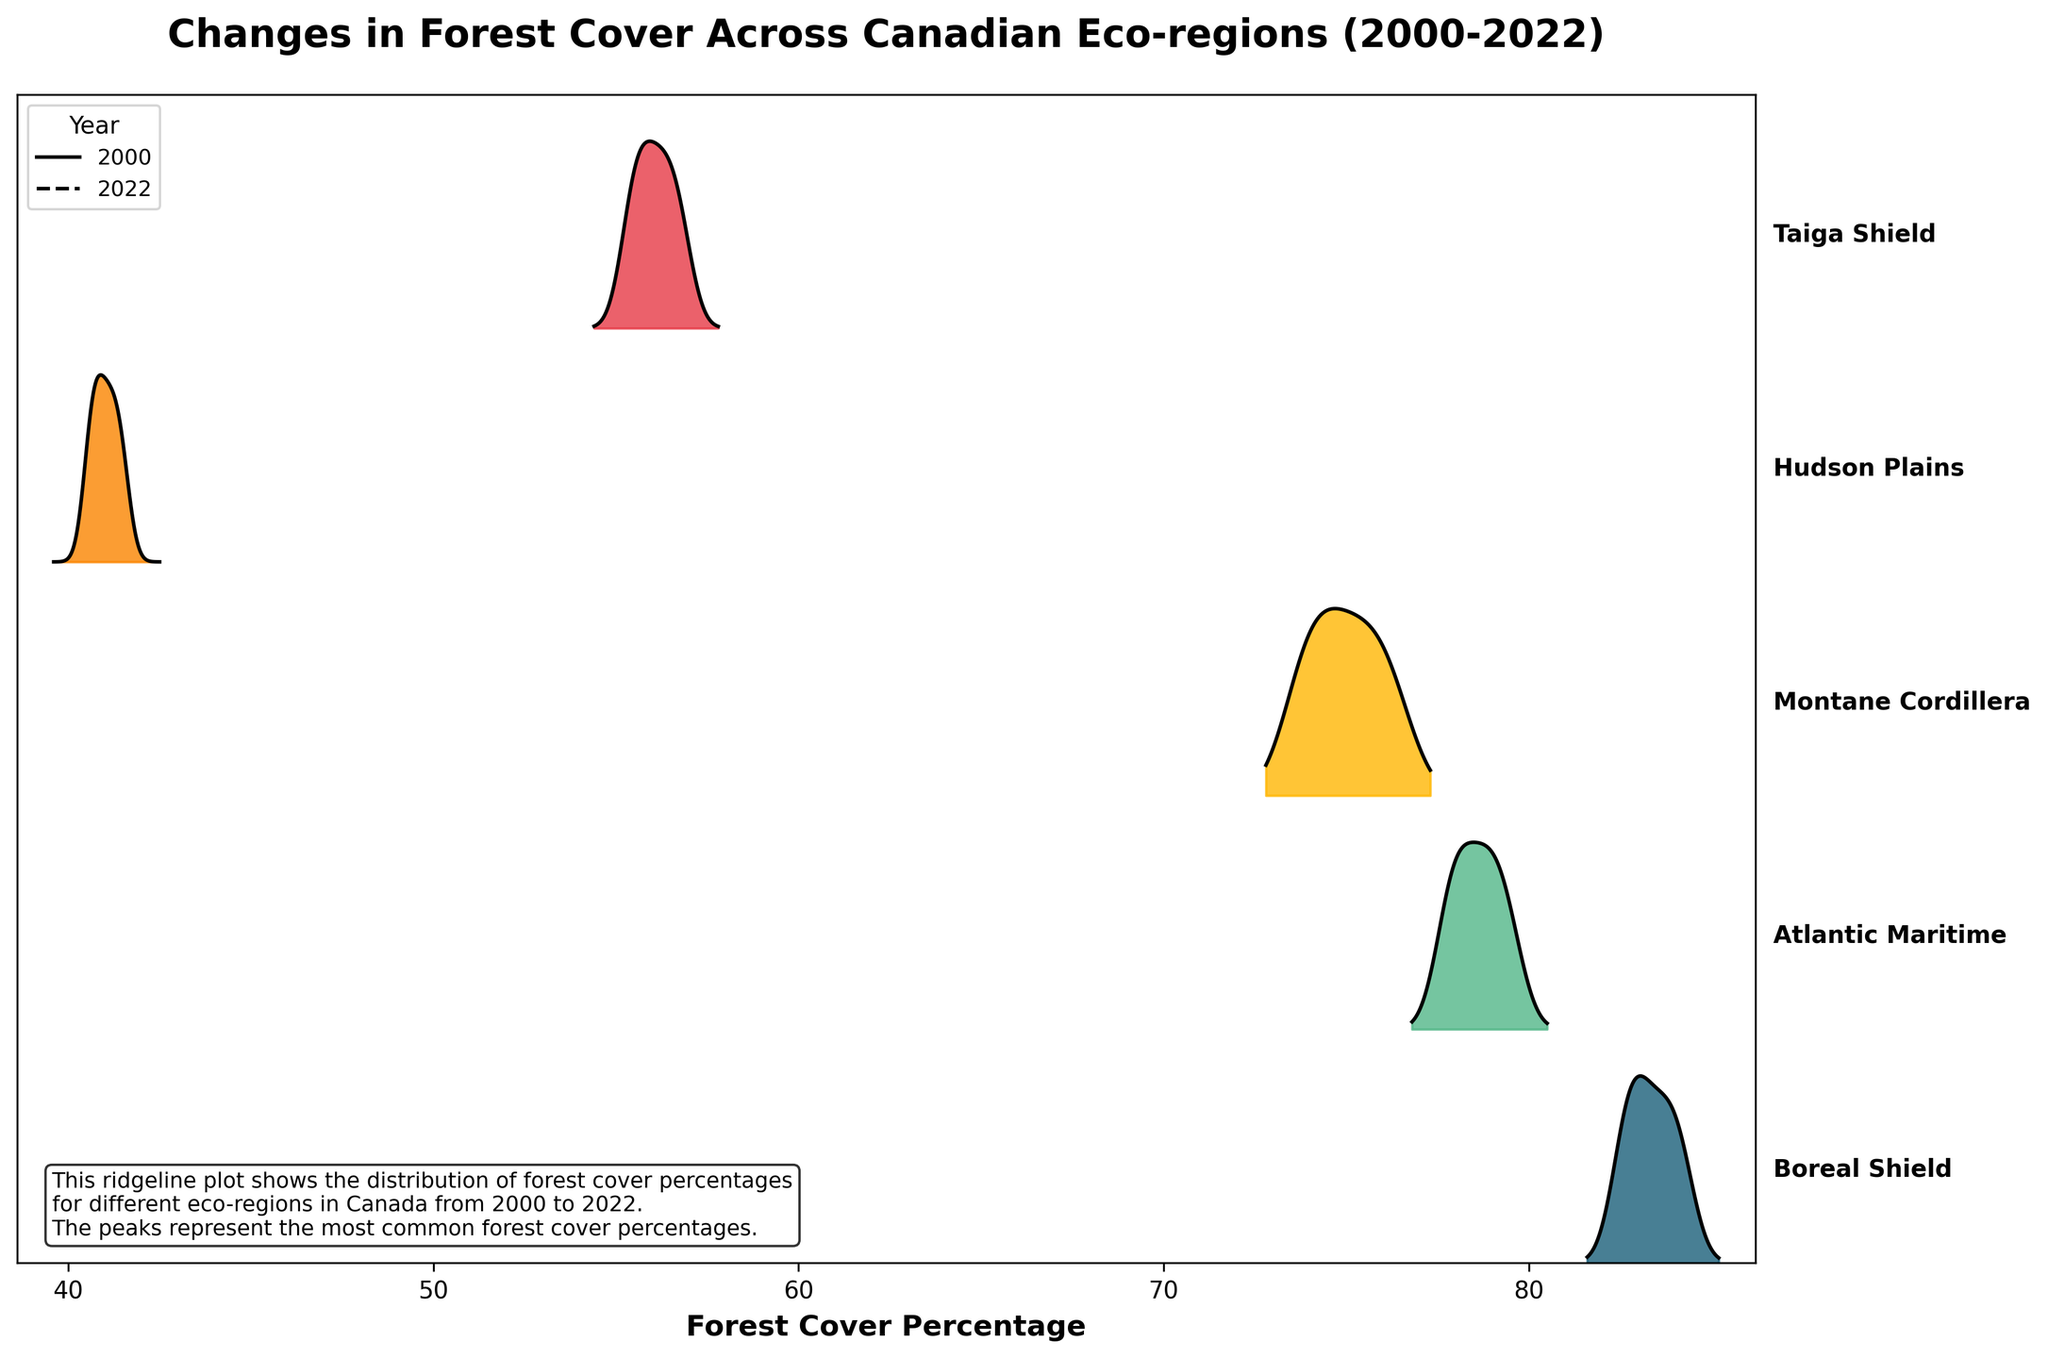What does the title of the figure indicate? The title of the figure, "Changes in Forest Cover Across Canadian Eco-regions (2000-2022)", clearly indicates that the plot shows the changes in forest cover percentages in different eco-regions of Canada from the year 2000 to 2022.
Answer: Changes in Forest Cover Across Canadian Eco-regions (2000-2022) Which eco-region has the highest forest cover in 2000? To determine this, look at the left side of each ridgeline to identify the peaks representing the year 2000. The Boreal Shield appears to have the highest peak value in 2000, which indicates that it has the highest forest cover percentage in that year.
Answer: Boreal Shield How does the forest cover percentage in the Atlantic Maritime region change from 2000 to 2022? The forest cover percentages start from 79.5% in 2000 and decrease to 77.8% in 2022, indicating a gradual decline over the years.
Answer: Gradual decline Compare the changes in forest cover percentage in the Boreal Shield and Taiga Shield from 2000 to 2022. Which region experienced a steeper decline? By comparing the slopes of the ridgelines, we can see that the Boreal Shield decreased from 84.2% to 82.6%, and the Taiga Shield decreased from 56.8% to 55.4% over the same period. The absolute change for the Boreal Shield is 1.6%, and for the Taiga Shield, it is 1.4%. Thus, the Boreal Shield experienced a slightly steeper decline.
Answer: Boreal Shield What can be inferred about the Hudson Plains region's forest cover trends from the plot? Observing the ridgeline for the Hudson Plains, the trend shows a slight but consistent decline from 41.5% in 2000 to 40.6% in 2022, indicating that changes in forest cover percentage are minimal compared to other regions.
Answer: Slight decline How do the forest cover percentages in 2022 compare across all eco-regions? To answer this, look at the peaks that represent the year 2022 for all ridgelines. The order from highest to lowest in 2022 is Boreal Shield, Atlantic Maritime, Montane Cordillera, Taiga Shield, and Hudson Plains.
Answer: Boreal Shield > Atlantic Maritime > Montane Cordillera > Taiga Shield > Hudson Plains Which eco-region shows the most stability in forest cover percentage from 2000 to 2022? The Hudson Plains' ridgeline shows the smallest changes in forest cover percentage over the years, indicating stability. The values remain close with minimal variation.
Answer: Hudson Plains Is there a significant difference in forest cover percentages between 2000 and 2020 in the Montane Cordillera region? The Montane Cordillera starts at 76.3% in 2000 and changes to 74.1% in 2020. This is a difference of 2.2%, which can be considered significant given the context of the data.
Answer: Yes, significant difference What does the color gradient in the plot represent? The color gradient in the ridgeline plot visually differentiates the various eco-regions, helping to distinguish between them easily on the chart.
Answer: Different eco-regions Which eco-region experienced the largest absolute decrease in forest cover percentage from 2000 to 2022? By calculating the absolute decrease for each eco-region: Boreal Shield (-1.6%), Atlantic Maritime (-1.7%), Montane Cordillera (-2.5%), Hudson Plains (-0.9%), and Taiga Shield (-1.4%), it is clear that the Montane Cordillera had the largest decrease.
Answer: Montane Cordillera 